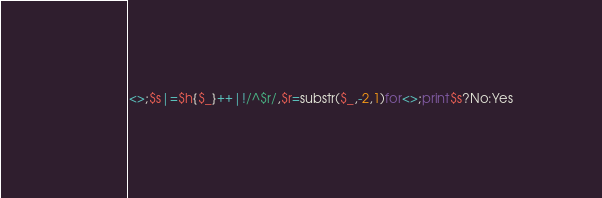<code> <loc_0><loc_0><loc_500><loc_500><_Perl_><>;$s|=$h{$_}++|!/^$r/,$r=substr($_,-2,1)for<>;print$s?No:Yes</code> 